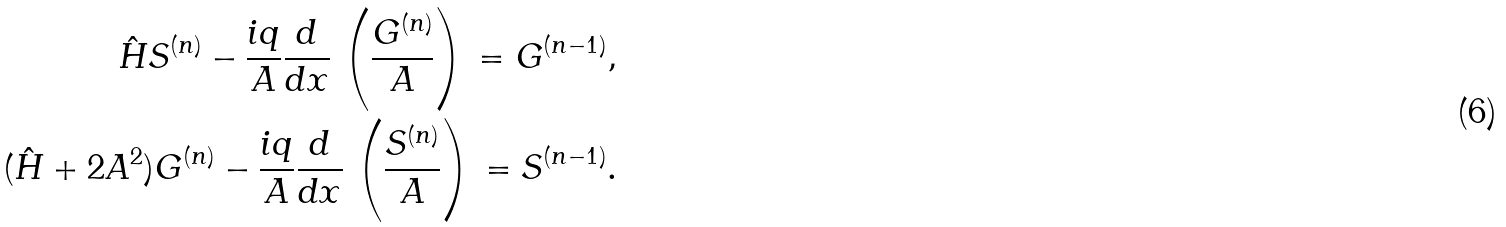<formula> <loc_0><loc_0><loc_500><loc_500>\hat { H } S ^ { ( n ) } - \frac { i q } { A } \frac { d } { d x } \, \left ( \frac { G ^ { ( n ) } } { A } \right ) \, = G ^ { ( n - 1 ) } , \\ ( \hat { H } + 2 A ^ { 2 } ) G ^ { ( n ) } - \frac { i q } { A } \frac { d } { d x } \, \left ( \frac { S ^ { ( n ) } } { A } \right ) \, = S ^ { ( n - 1 ) } .</formula> 